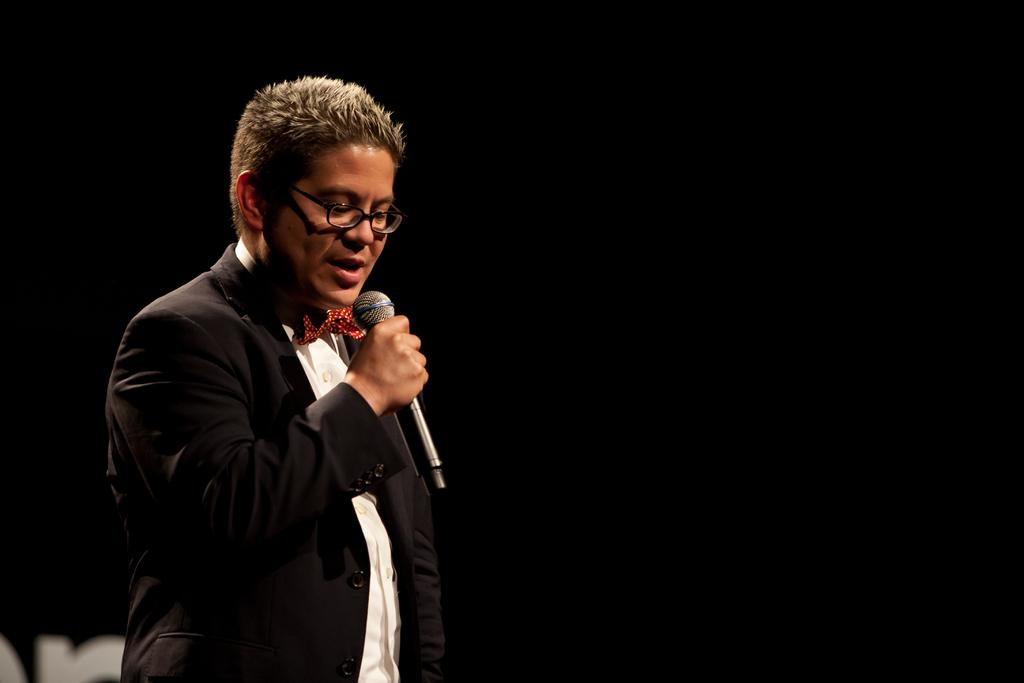What is the main subject of the image? There is a person in the image. What is the person doing in the image? The person is standing. What object is the person holding in the image? The person is holding a mic in his hand. What type of debt is the person discussing in the image? There is no indication in the image that the person is discussing any type of debt. 